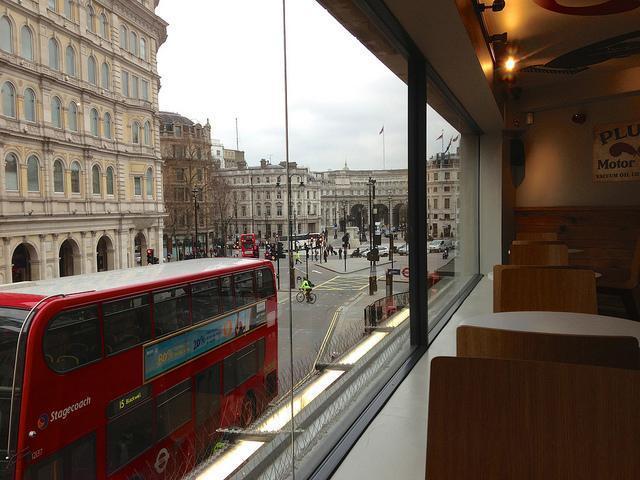How many chairs are there?
Give a very brief answer. 3. 